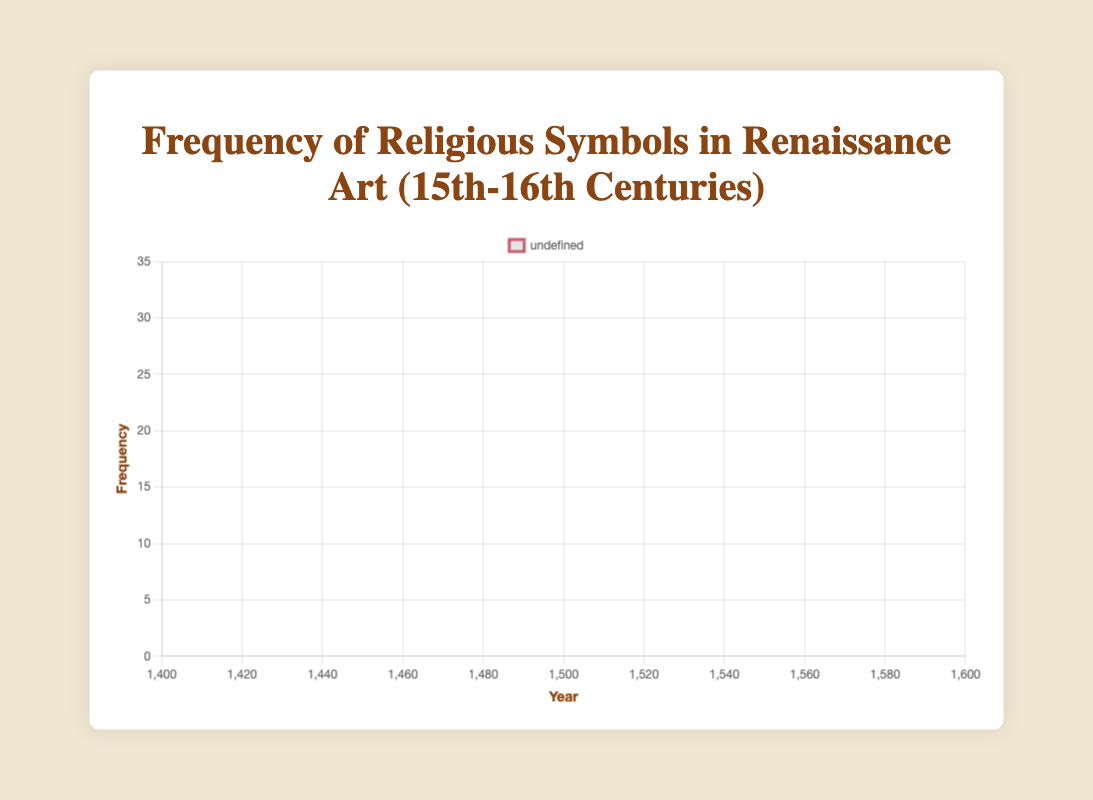Which religious symbol reaches the highest frequency overall? Observing the peaks of each curve, "Madonna and Child" reached the highest frequency overall in 1520 with a value of 30.
Answer: Madonna and Child Between which years did the frequency of "Crucifixion" increase the most? From 1460 to 1480, the frequency of "Crucifixion" increased from 14 to 20, resulting in an increase of 6.
Answer: 1460 to 1480 In which year did "Nativity Scene" surpass "Annunciation" in frequency? By comparing the curves, "Nativity Scene" surpassed "Annunciation" in 1540 when "Nativity Scene" had 21 and "Annunciation" had 11.
Answer: 1540 What is the average frequency of "The Last Supper" from 1400 to 1580? Summing the frequencies (1 + 2 + 4 + 8 + 11 + 14 + 13 + 10 + 8 + 5) equals 76. Average is 76/10 = 7.6.
Answer: 7.6 Which symbol had the steepest decline in frequency after reaching its peak? "Crucifixion" peaked at 22 in 1500 and declined steadily to 10 by 1580, showing a steep decline by 12 units.
Answer: Crucifixion During which decade did "Madonna and Child" see the most significant increase in frequency? From the 1460s to the 1480s, "Madonna and Child" frequency increased from 18 to 25, a rise of 7 units.
Answer: 1460s to 1480s How many years did it take for "Crucifixion" to reach its peak frequency? "Crucifixion" started at 5 units in 1400 and peaked at 22 units in 1500, taking 100 years.
Answer: 100 years Which two symbols have the closest frequencies in 1580? In 1580, "Madonna and Child" is at 19 and "Nativity Scene" is at 15, with a difference of 4, the smallest compared to other pairs.
Answer: Madonna and Child and Nativity Scene What was the overall trend in frequency for "Annunciation" from 1400 to 1580? "Annunciation" showed an increasing trend from 2 in 1400 to peak at 18 in 1500, then steadily decreased to 6 by 1580.
Answer: Increasing then decreasing 